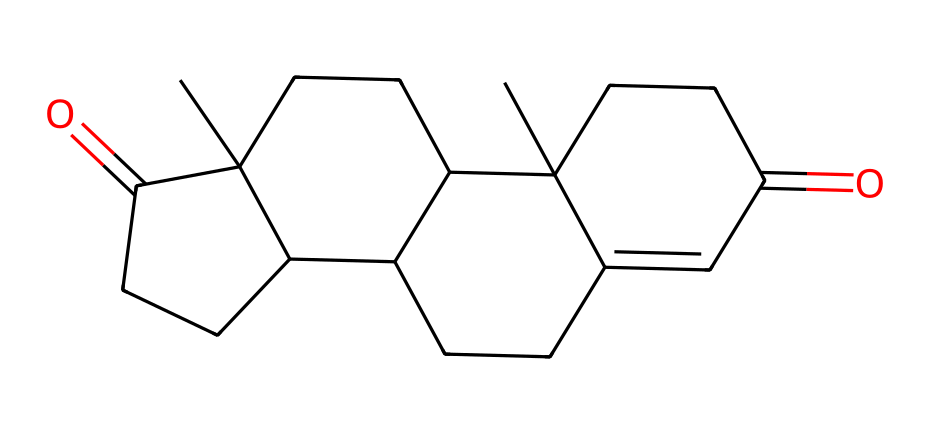How many carbon atoms are in progesterone? Analyzing the SMILES representation, we count the number of carbon atoms denoted by the "C" symbols. There are a total of 21 carbon atoms present in the structure.
Answer: 21 What type of chemical is progesterone classified as? By examining the structure and functional groups, we find that progesterone is a steroid hormone, as characterized by its four interconnected carbon rings.
Answer: steroid hormone What is the significance of progesterone in women's health? Progesterone plays a crucial role in regulating the menstrual cycle, preparing the body for pregnancy, and maintaining early stages of pregnancy, thus making it vital for reproductive health.
Answer: reproductive health What is the molecular formula of progesterone? By interpreting the counts of carbon, hydrogen, and oxygen from the SMILES, we determine the molecular formula C21H30O2. The structure contains 21 carbons, 30 hydrogens, and 2 oxygens.
Answer: C21H30O2 How many hydrogen atoms are present in progesterone? Counting the hydrogen atoms in the structure requires an understanding of each carbon's bonding within the SMILES. Each carbon typically forms four bonds; in this case, there are 30 hydrogen atoms in the molecular structure.
Answer: 30 What functional groups are present in progesterone? The presence of ketone groups (=O) in its structure indicates the presence of carbonyl functional groups. In progesterone, it has two ketone functionalities contributing to its activity as a hormone.
Answer: ketone groups How does progesterone affect career progression in women? Progesterone influences various physiological processes related to women's health, which can indirectly affect aspects like mental health, work-life balance, and overall well-being, ultimately impacting career progression.
Answer: indirectly affects 